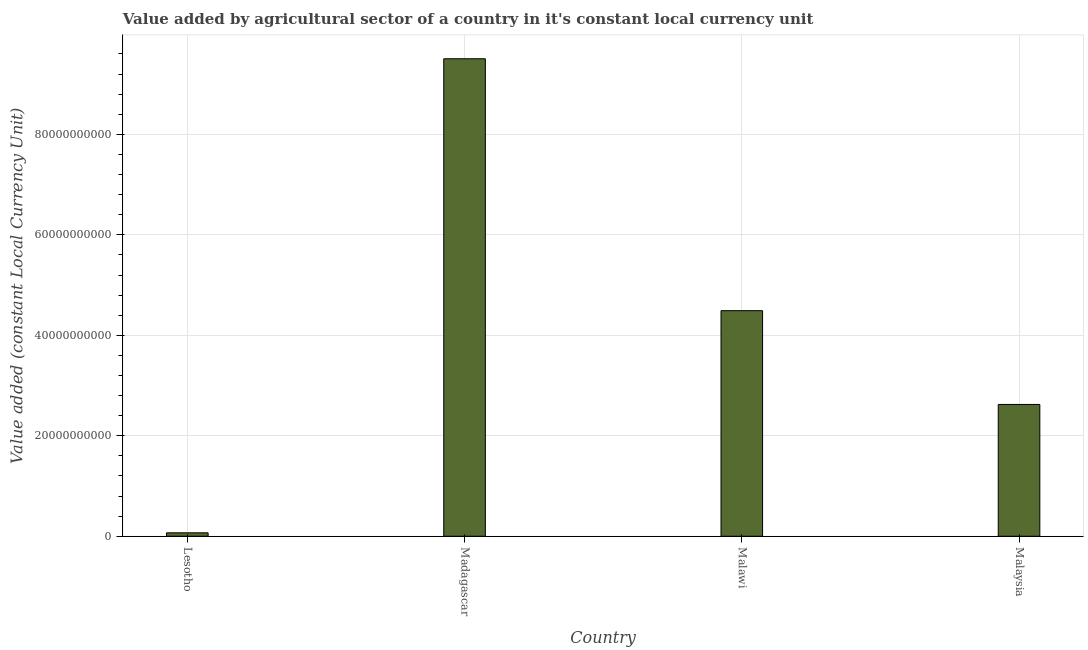Does the graph contain any zero values?
Provide a short and direct response. No. What is the title of the graph?
Provide a short and direct response. Value added by agricultural sector of a country in it's constant local currency unit. What is the label or title of the Y-axis?
Your answer should be very brief. Value added (constant Local Currency Unit). What is the value added by agriculture sector in Malaysia?
Your answer should be compact. 2.62e+1. Across all countries, what is the maximum value added by agriculture sector?
Give a very brief answer. 9.51e+1. Across all countries, what is the minimum value added by agriculture sector?
Your response must be concise. 6.81e+08. In which country was the value added by agriculture sector maximum?
Ensure brevity in your answer.  Madagascar. In which country was the value added by agriculture sector minimum?
Ensure brevity in your answer.  Lesotho. What is the sum of the value added by agriculture sector?
Keep it short and to the point. 1.67e+11. What is the difference between the value added by agriculture sector in Lesotho and Malaysia?
Your answer should be very brief. -2.56e+1. What is the average value added by agriculture sector per country?
Your answer should be compact. 4.17e+1. What is the median value added by agriculture sector?
Provide a succinct answer. 3.56e+1. In how many countries, is the value added by agriculture sector greater than 24000000000 LCU?
Keep it short and to the point. 3. What is the ratio of the value added by agriculture sector in Lesotho to that in Malawi?
Keep it short and to the point. 0.01. Is the value added by agriculture sector in Lesotho less than that in Malaysia?
Give a very brief answer. Yes. What is the difference between the highest and the second highest value added by agriculture sector?
Your answer should be very brief. 5.02e+1. Is the sum of the value added by agriculture sector in Madagascar and Malaysia greater than the maximum value added by agriculture sector across all countries?
Provide a succinct answer. Yes. What is the difference between the highest and the lowest value added by agriculture sector?
Your answer should be compact. 9.44e+1. In how many countries, is the value added by agriculture sector greater than the average value added by agriculture sector taken over all countries?
Give a very brief answer. 2. How many bars are there?
Provide a short and direct response. 4. What is the Value added (constant Local Currency Unit) of Lesotho?
Your answer should be compact. 6.81e+08. What is the Value added (constant Local Currency Unit) in Madagascar?
Your answer should be very brief. 9.51e+1. What is the Value added (constant Local Currency Unit) in Malawi?
Your answer should be very brief. 4.49e+1. What is the Value added (constant Local Currency Unit) in Malaysia?
Provide a succinct answer. 2.62e+1. What is the difference between the Value added (constant Local Currency Unit) in Lesotho and Madagascar?
Your answer should be compact. -9.44e+1. What is the difference between the Value added (constant Local Currency Unit) in Lesotho and Malawi?
Keep it short and to the point. -4.42e+1. What is the difference between the Value added (constant Local Currency Unit) in Lesotho and Malaysia?
Ensure brevity in your answer.  -2.56e+1. What is the difference between the Value added (constant Local Currency Unit) in Madagascar and Malawi?
Offer a terse response. 5.02e+1. What is the difference between the Value added (constant Local Currency Unit) in Madagascar and Malaysia?
Offer a very short reply. 6.88e+1. What is the difference between the Value added (constant Local Currency Unit) in Malawi and Malaysia?
Offer a very short reply. 1.87e+1. What is the ratio of the Value added (constant Local Currency Unit) in Lesotho to that in Madagascar?
Ensure brevity in your answer.  0.01. What is the ratio of the Value added (constant Local Currency Unit) in Lesotho to that in Malawi?
Ensure brevity in your answer.  0.01. What is the ratio of the Value added (constant Local Currency Unit) in Lesotho to that in Malaysia?
Give a very brief answer. 0.03. What is the ratio of the Value added (constant Local Currency Unit) in Madagascar to that in Malawi?
Your answer should be very brief. 2.12. What is the ratio of the Value added (constant Local Currency Unit) in Madagascar to that in Malaysia?
Ensure brevity in your answer.  3.62. What is the ratio of the Value added (constant Local Currency Unit) in Malawi to that in Malaysia?
Your answer should be very brief. 1.71. 